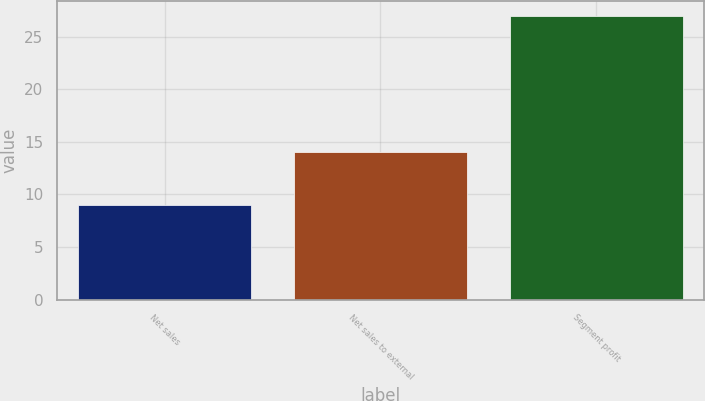<chart> <loc_0><loc_0><loc_500><loc_500><bar_chart><fcel>Net sales<fcel>Net sales to external<fcel>Segment profit<nl><fcel>9<fcel>14<fcel>27<nl></chart> 